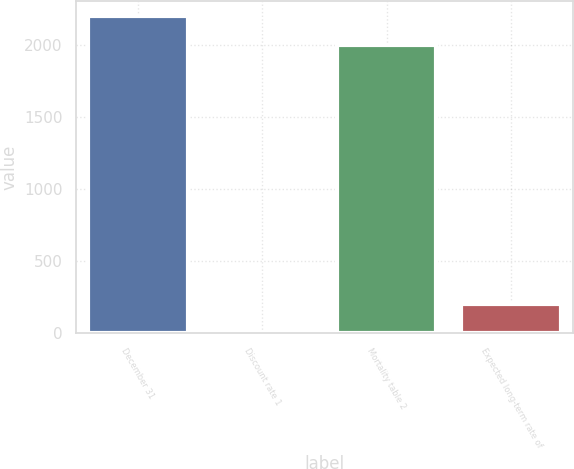Convert chart. <chart><loc_0><loc_0><loc_500><loc_500><bar_chart><fcel>December 31<fcel>Discount rate 1<fcel>Mortality table 2<fcel>Expected long-term rate of<nl><fcel>2200.81<fcel>4.9<fcel>2000<fcel>205.71<nl></chart> 